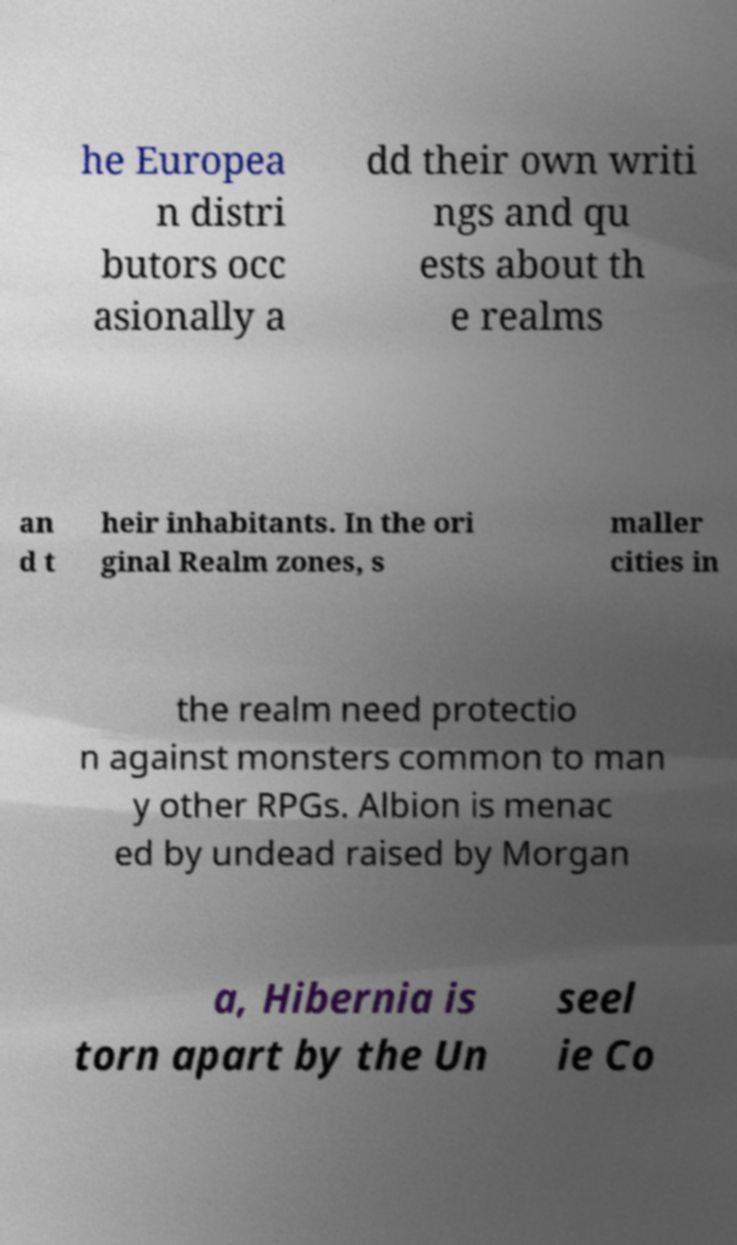I need the written content from this picture converted into text. Can you do that? he Europea n distri butors occ asionally a dd their own writi ngs and qu ests about th e realms an d t heir inhabitants. In the ori ginal Realm zones, s maller cities in the realm need protectio n against monsters common to man y other RPGs. Albion is menac ed by undead raised by Morgan a, Hibernia is torn apart by the Un seel ie Co 